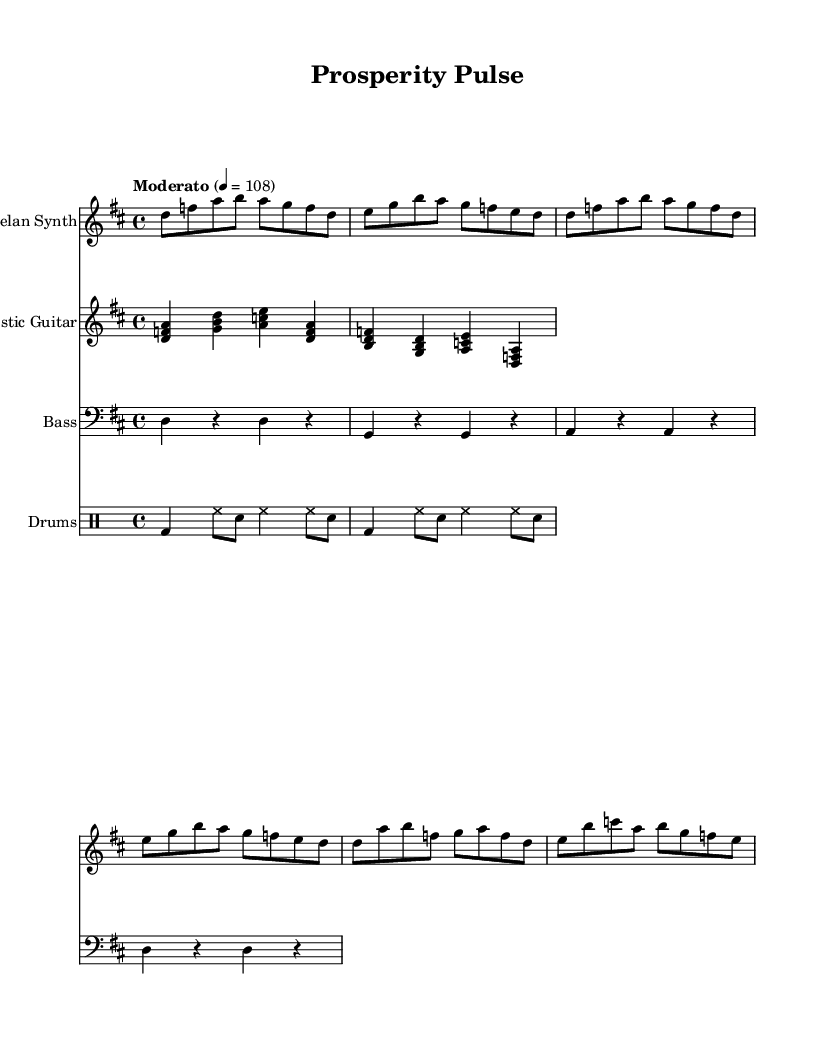What is the key signature of this music? The key signature is D major, which has two sharps: F# and C#. This can be identified by the presence of the sharp symbols placed on the fifth line from the bottom of the staff.
Answer: D major What is the time signature of this music? The time signature is 4/4, indicated at the beginning of the piece. This means there are four beats in each measure and a quarter note receives one beat.
Answer: 4/4 What is the tempo marking for this piece? The tempo marking is "Moderato", and it specifies a tempo of 108 beats per minute, indicated at the beginning of the music.
Answer: Moderato Which instruments are featured in this piece? The instruments featured are Gamelan Synth, Acoustic Guitar, Bass, and Drums. This is displayed at the beginning of each staff with their respective instrument names.
Answer: Gamelan Synth, Acoustic Guitar, Bass, Drums How many measures are there in the Gamelan Synth part? The Gamelan Synth part consists of 6 measures. By counting the vertical bar lines in the staff, we can determine the total number of measures included.
Answer: 6 What rhythmic pattern is used in the Drums part? The Drums part uses a pattern combining bass drum (bd), hi-hat (hh), and snare drum (sn) in a repetitive sequence, allowing us to analyze the rhythmic texture of the composition.
Answer: Bass, hi-hat, snare 